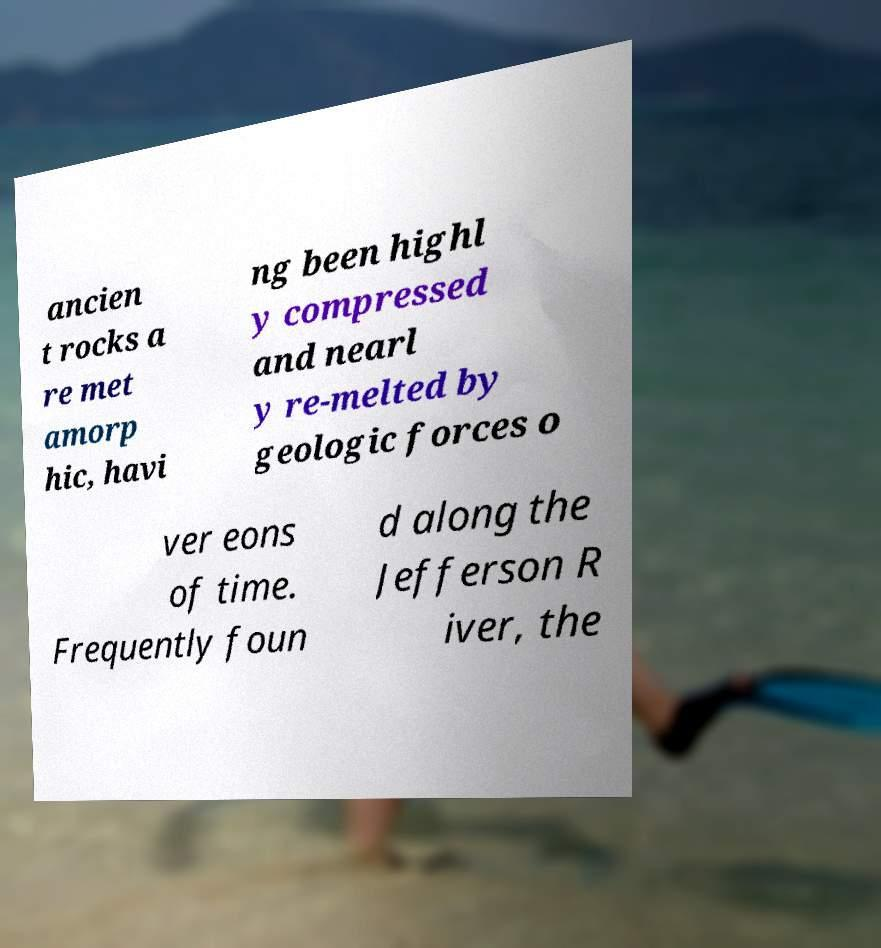I need the written content from this picture converted into text. Can you do that? ancien t rocks a re met amorp hic, havi ng been highl y compressed and nearl y re-melted by geologic forces o ver eons of time. Frequently foun d along the Jefferson R iver, the 